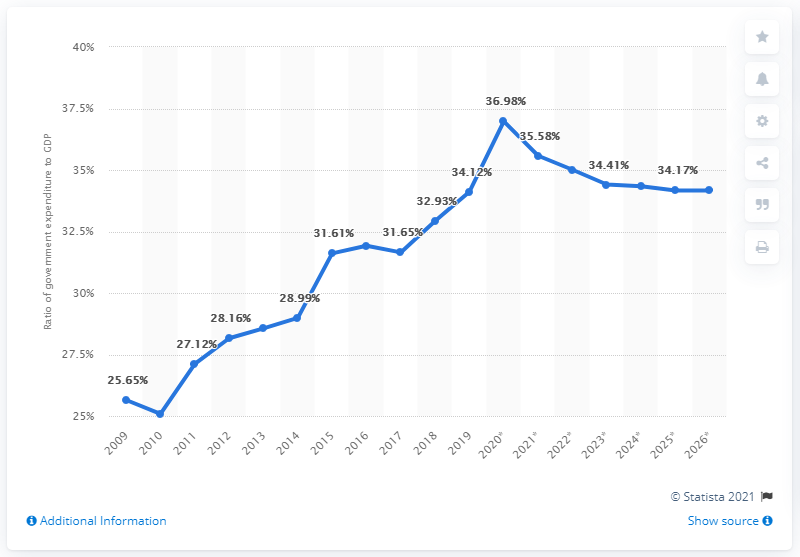Specify some key components in this picture. In 2019, China's public spending ratio was 34.17%. 